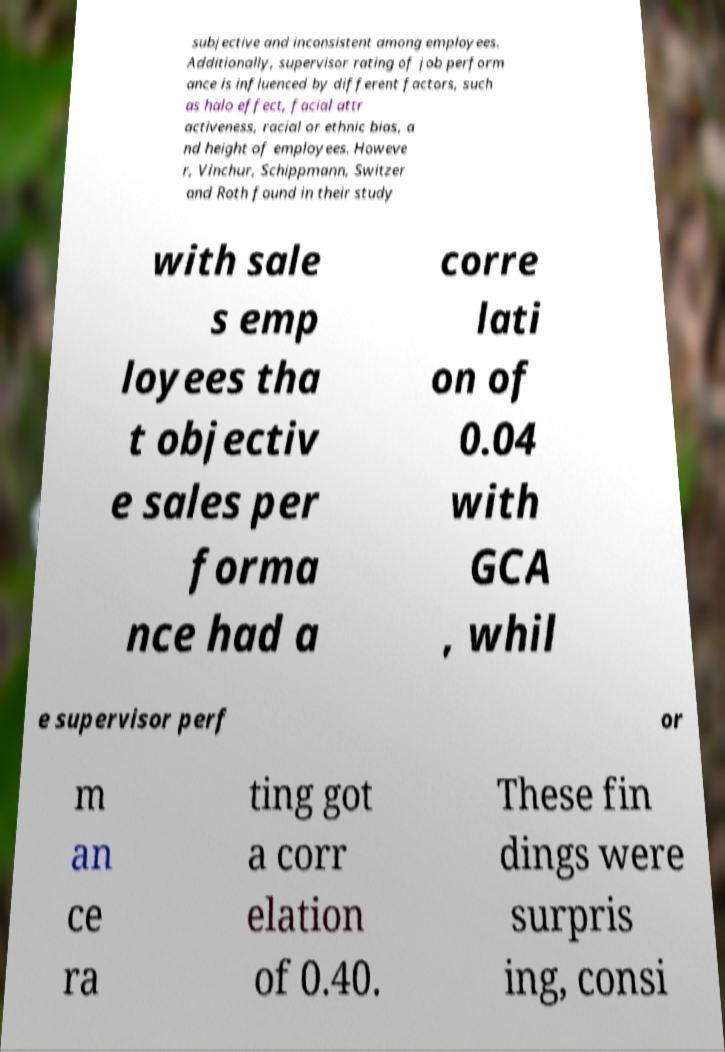Could you extract and type out the text from this image? subjective and inconsistent among employees. Additionally, supervisor rating of job perform ance is influenced by different factors, such as halo effect, facial attr activeness, racial or ethnic bias, a nd height of employees. Howeve r, Vinchur, Schippmann, Switzer and Roth found in their study with sale s emp loyees tha t objectiv e sales per forma nce had a corre lati on of 0.04 with GCA , whil e supervisor perf or m an ce ra ting got a corr elation of 0.40. These fin dings were surpris ing, consi 